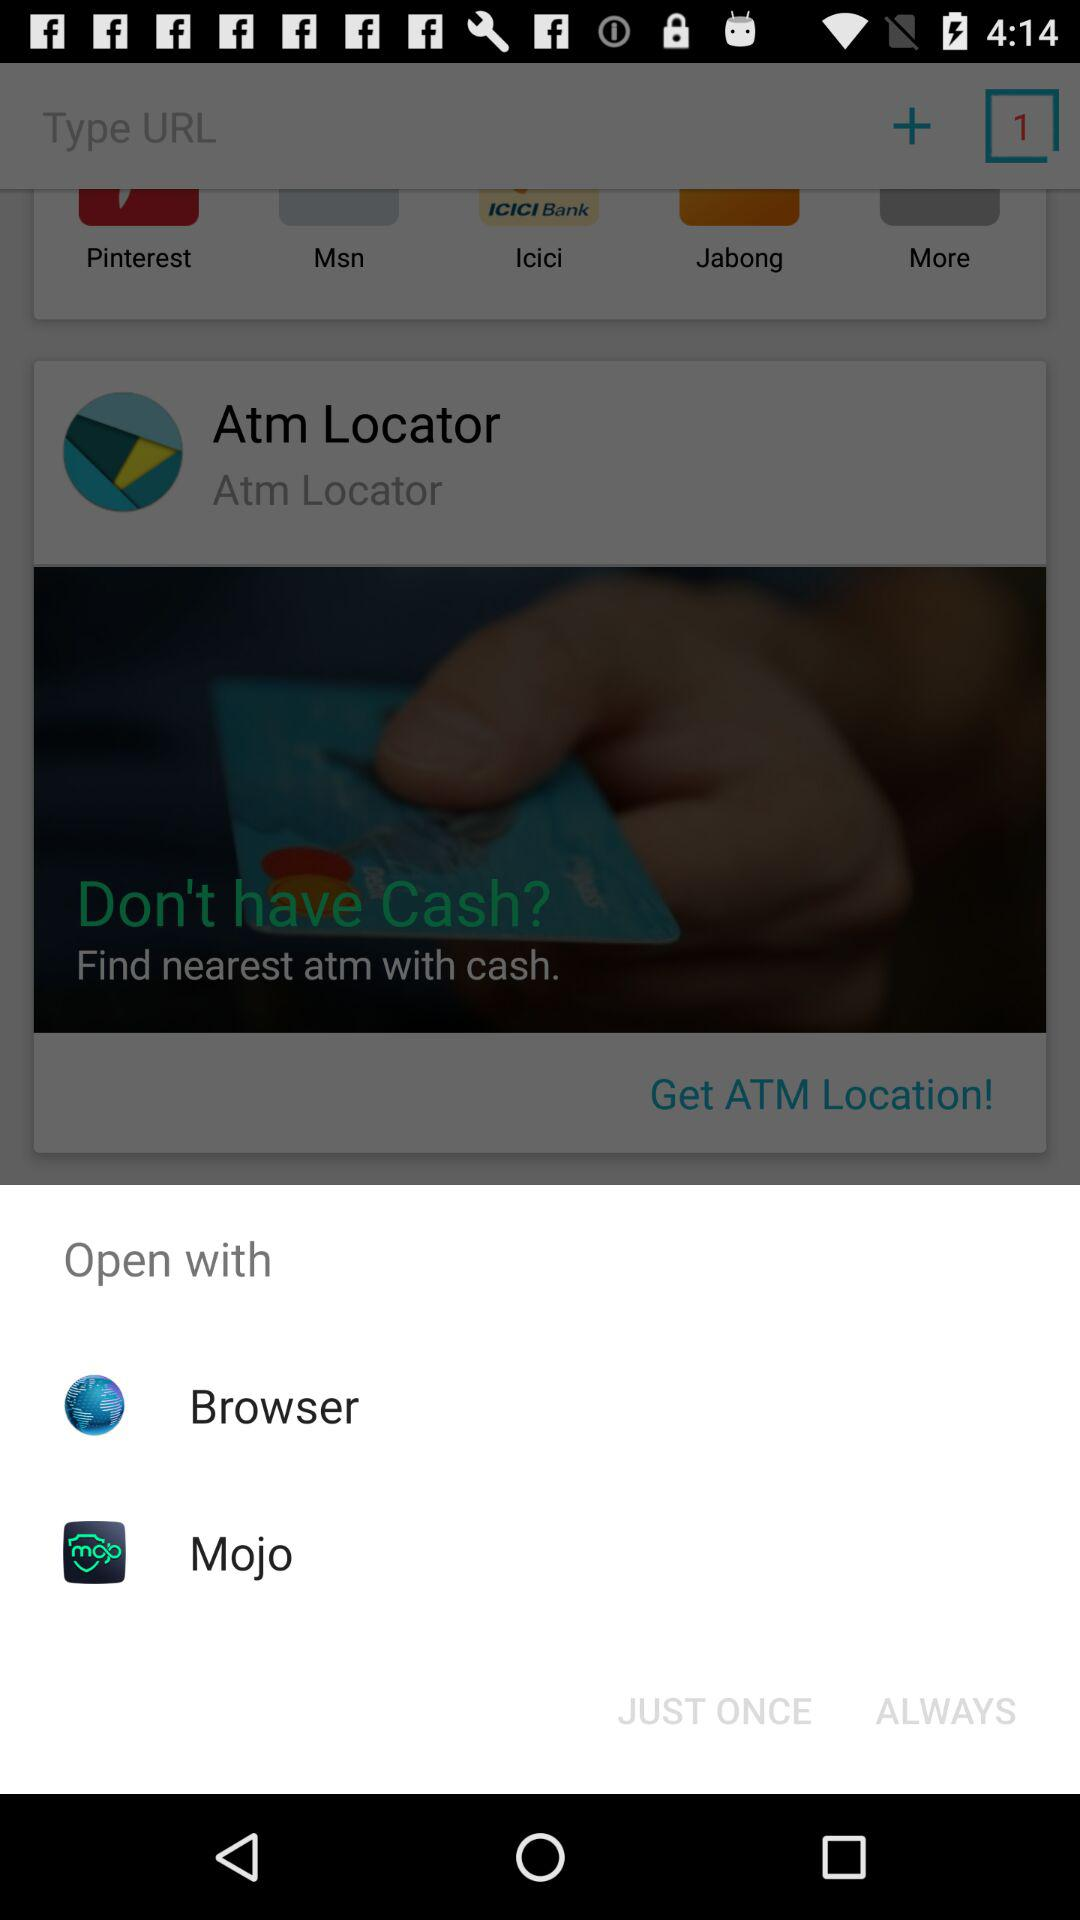What are the different applications to open? The applications are "Browser" and "Mojo". 